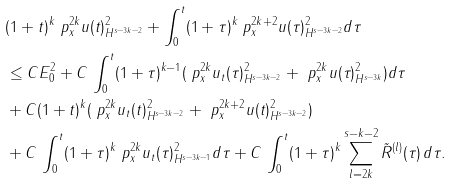<formula> <loc_0><loc_0><loc_500><loc_500>& ( 1 + t ) ^ { k } \| \ p ^ { 2 k } _ { x } u ( t ) \| ^ { 2 } _ { H ^ { s - 3 k - 2 } } + \int ^ { t } _ { 0 } ( 1 + \tau ) ^ { k } \| \ p ^ { 2 k + 2 } _ { x } u ( \tau ) \| ^ { 2 } _ { H ^ { s - 3 k - 2 } } d \tau \\ & \leq C E _ { 0 } ^ { 2 } + C \, \int ^ { t } _ { 0 } ( 1 + \tau ) ^ { k - 1 } ( \| \ p ^ { 2 k } _ { x } u _ { t } ( \tau ) \| ^ { 2 } _ { H ^ { s - 3 k - 2 } } + \| \ p ^ { 2 k } _ { x } u ( \tau ) \| ^ { 2 } _ { H ^ { s - 3 k } } ) d \tau \\ & + C ( 1 + t ) ^ { k } ( \| \ p ^ { 2 k } _ { x } u _ { t } ( t ) \| ^ { 2 } _ { H ^ { s - 3 k - 2 } } + \| \ p ^ { 2 k + 2 } _ { x } u ( t ) \| ^ { 2 } _ { H ^ { s - 3 k - 2 } } ) \\ & + C \, \int ^ { t } _ { 0 } ( 1 + \tau ) ^ { k } \| \ p ^ { 2 k } _ { x } u _ { t } ( \tau ) \| ^ { 2 } _ { H ^ { s - 3 k - 1 } } d \tau + C \, \int ^ { t } _ { 0 } ( 1 + \tau ) ^ { k } \sum _ { l = 2 k } ^ { s - k - 2 } \tilde { R } ^ { ( l ) } ( \tau ) \, d \tau .</formula> 